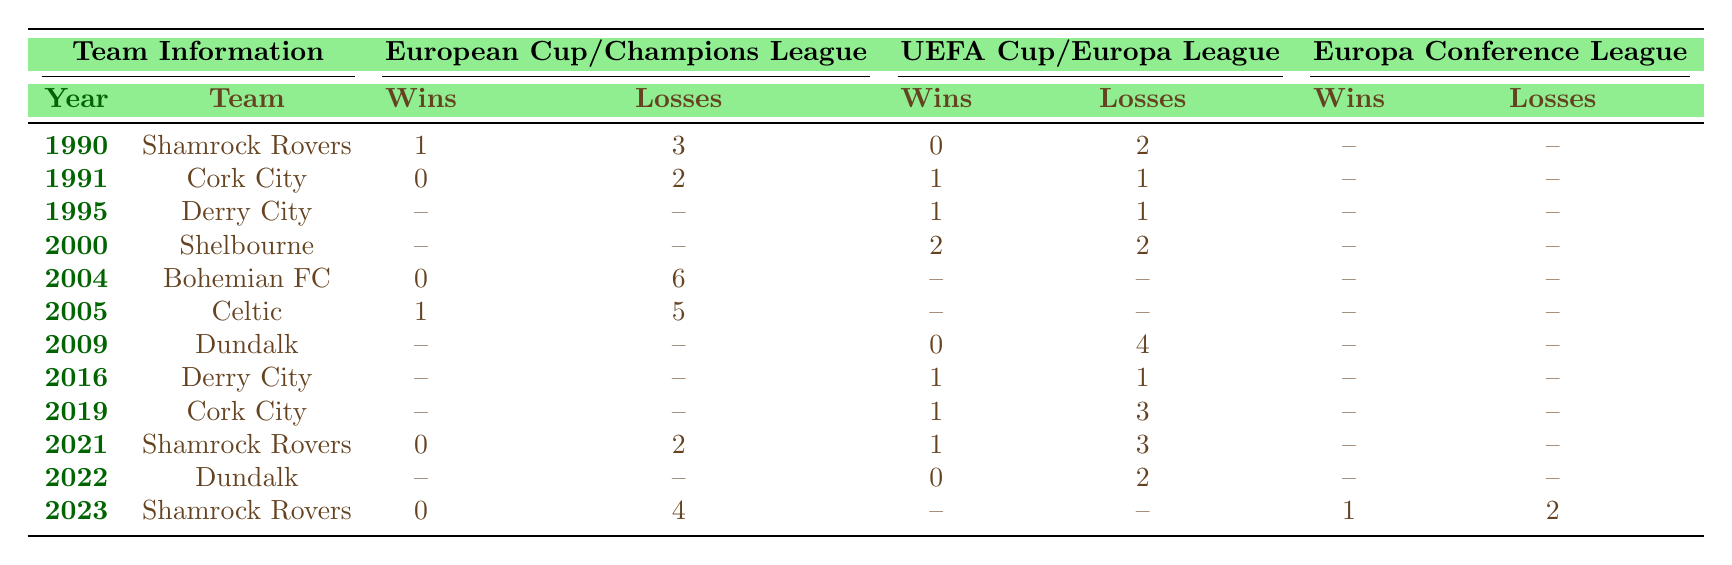What is the total number of wins for Shamrock Rovers from 1990 to 2023? To find the total wins for Shamrock Rovers, I will refer to the years 1990 and 2021, where they had 1 win in 1990 and 0 wins in 2021. In 2023, they had 0 wins in the Champions League and 1 win in the Europa Conference League. Summing these gives 1 + 0 + 1 = 2.
Answer: 2 Which team had the highest number of losses in the Champions League? The table shows that Bohemian FC had 6 losses in the Champions League in 2004, while Shamrock Rovers had 2 losses in 2021 and Celtic had 5 losses in 2005. Therefore, Bohemian FC has the highest number of losses.
Answer: Bohemian FC Did Derry City achieve any wins in the UEFA Cup during the years listed? In 1995, Derry City had 1 win and 1 loss in the UEFA Cup. The other instance in 2016 also shows they had 1 win and 1 loss. Therefore, they did achieve wins in the UEFA Cup over the years listed.
Answer: Yes What is the combined total of wins for Cork City across all competitions from 1991 to 2019? Cork City had 0 wins in 1991, 1 win in 1991 from the UEFA Cup, and 1 win in 2019 from the Europa League. Adding these gives a total of 0 + 1 + 1 = 2.
Answer: 2 Which team experienced a loss without a win in any European competition from 1990 to 2023? Referring to the table, Bohemian FC had 0 wins and 6 losses in the Champions League in 2004, indicating they did not win any matches during that season.
Answer: Bohemian FC What is the total number of losses for all teams in the Europa League from 2000 to 2023? Adding the losses for each relevant year: Dundalk in 2009 had 4 losses, Derry City in 2016 had 1 loss, Cork City in 2019 had 3 losses, Shamrock Rovers in 2021 had 3 losses, and Dundalk in 2022 had 2 losses. The total is 4 + 1 + 3 + 3 + 2 = 13.
Answer: 13 In which year did Shamrock Rovers have their only win in international competition? Checking the table entries, Shamrock Rovers had a win in 1990 in the European Cup and 1 win in 2023 in the Europa Conference League.
Answer: 1990 and 2023 Which Irish team recorded a win-loss balance of exactly 0 in the UEFA Cup? Looking at the table for the UEFA Cup data, Cork City's record shows they had 1 win and 1 loss in 1991, and Derry City had 1 win and 1 loss in 2016. Therefore, Cork City and Derry City both have a record of balance 0.
Answer: Cork City and Derry City 